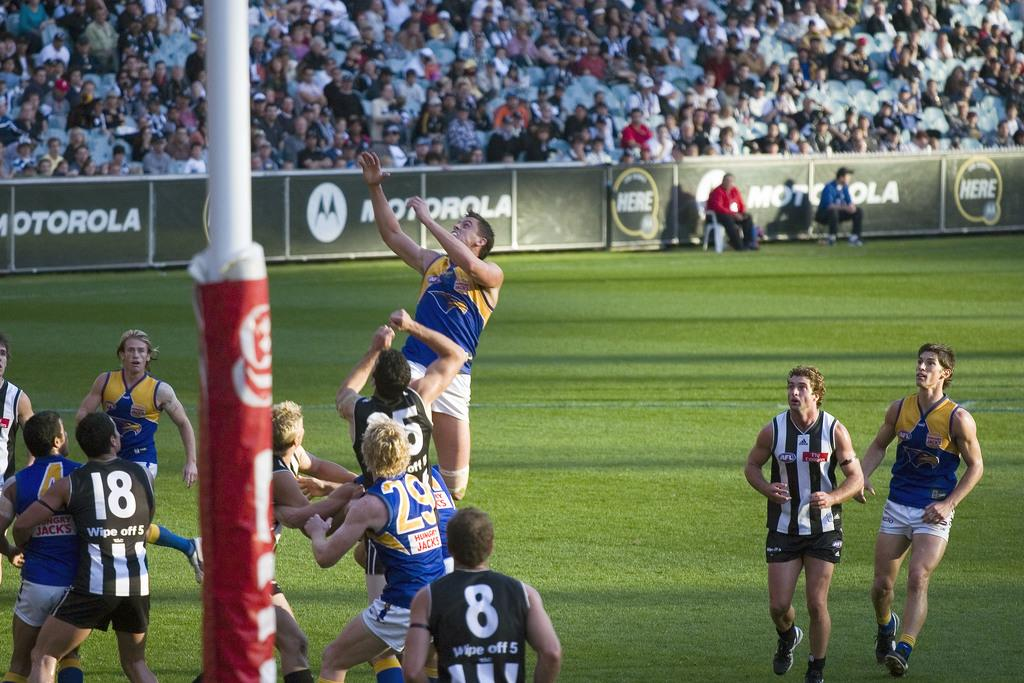<image>
Share a concise interpretation of the image provided. Number 18 and 8 watch as a player from the other team makes a high leap. 